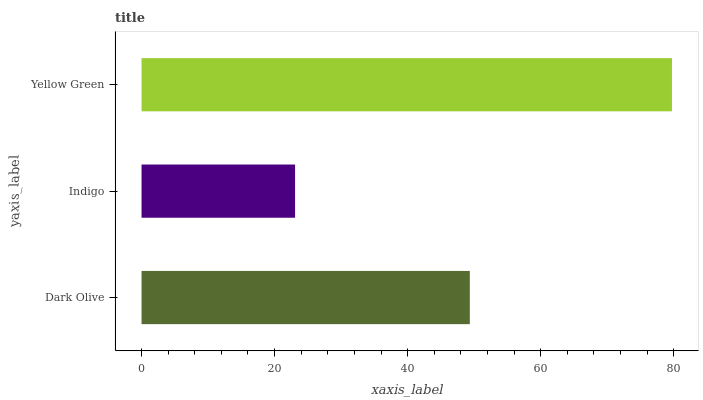Is Indigo the minimum?
Answer yes or no. Yes. Is Yellow Green the maximum?
Answer yes or no. Yes. Is Yellow Green the minimum?
Answer yes or no. No. Is Indigo the maximum?
Answer yes or no. No. Is Yellow Green greater than Indigo?
Answer yes or no. Yes. Is Indigo less than Yellow Green?
Answer yes or no. Yes. Is Indigo greater than Yellow Green?
Answer yes or no. No. Is Yellow Green less than Indigo?
Answer yes or no. No. Is Dark Olive the high median?
Answer yes or no. Yes. Is Dark Olive the low median?
Answer yes or no. Yes. Is Indigo the high median?
Answer yes or no. No. Is Indigo the low median?
Answer yes or no. No. 